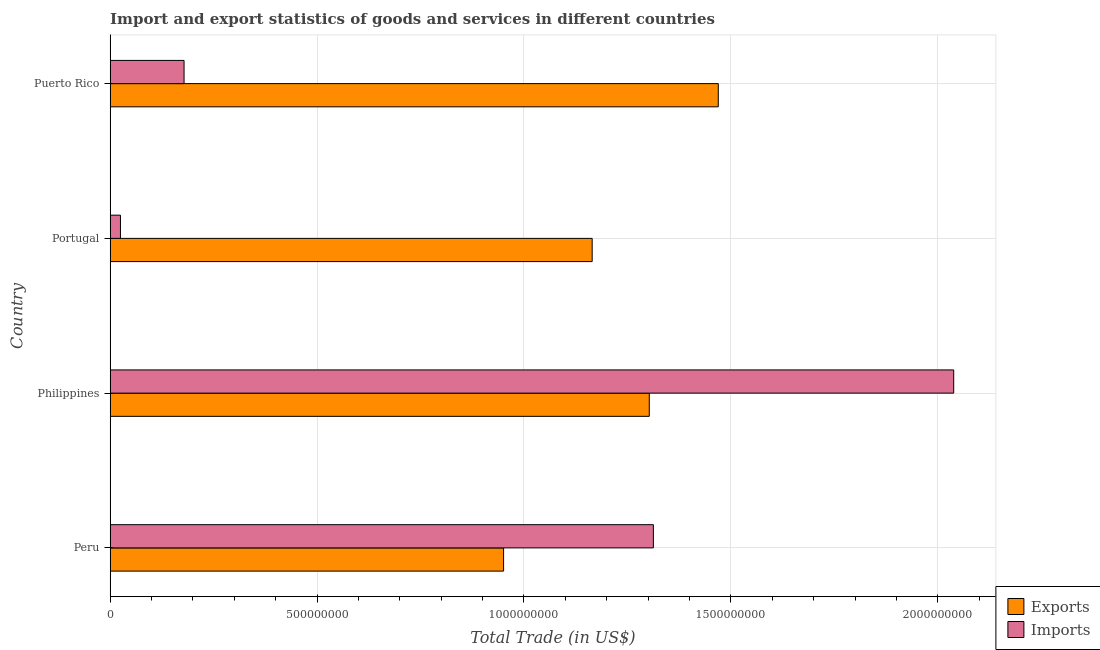How many different coloured bars are there?
Ensure brevity in your answer.  2. How many groups of bars are there?
Keep it short and to the point. 4. What is the imports of goods and services in Philippines?
Give a very brief answer. 2.04e+09. Across all countries, what is the maximum export of goods and services?
Your answer should be compact. 1.47e+09. Across all countries, what is the minimum export of goods and services?
Your response must be concise. 9.51e+08. In which country was the export of goods and services minimum?
Offer a terse response. Peru. What is the total imports of goods and services in the graph?
Your answer should be compact. 3.55e+09. What is the difference between the imports of goods and services in Peru and that in Puerto Rico?
Your response must be concise. 1.13e+09. What is the difference between the export of goods and services in Philippines and the imports of goods and services in Peru?
Make the answer very short. -9.93e+06. What is the average export of goods and services per country?
Keep it short and to the point. 1.22e+09. What is the difference between the imports of goods and services and export of goods and services in Puerto Rico?
Keep it short and to the point. -1.29e+09. In how many countries, is the imports of goods and services greater than 500000000 US$?
Provide a short and direct response. 2. What is the ratio of the export of goods and services in Peru to that in Philippines?
Make the answer very short. 0.73. Is the difference between the export of goods and services in Portugal and Puerto Rico greater than the difference between the imports of goods and services in Portugal and Puerto Rico?
Give a very brief answer. No. What is the difference between the highest and the second highest imports of goods and services?
Give a very brief answer. 7.26e+08. What is the difference between the highest and the lowest imports of goods and services?
Keep it short and to the point. 2.01e+09. What does the 2nd bar from the top in Peru represents?
Provide a succinct answer. Exports. What does the 1st bar from the bottom in Puerto Rico represents?
Your answer should be compact. Exports. How many bars are there?
Give a very brief answer. 8. Are all the bars in the graph horizontal?
Give a very brief answer. Yes. How many countries are there in the graph?
Keep it short and to the point. 4. Are the values on the major ticks of X-axis written in scientific E-notation?
Offer a very short reply. No. How many legend labels are there?
Offer a very short reply. 2. What is the title of the graph?
Provide a short and direct response. Import and export statistics of goods and services in different countries. What is the label or title of the X-axis?
Give a very brief answer. Total Trade (in US$). What is the label or title of the Y-axis?
Your answer should be very brief. Country. What is the Total Trade (in US$) in Exports in Peru?
Your answer should be compact. 9.51e+08. What is the Total Trade (in US$) of Imports in Peru?
Offer a terse response. 1.31e+09. What is the Total Trade (in US$) of Exports in Philippines?
Give a very brief answer. 1.30e+09. What is the Total Trade (in US$) of Imports in Philippines?
Provide a succinct answer. 2.04e+09. What is the Total Trade (in US$) of Exports in Portugal?
Keep it short and to the point. 1.16e+09. What is the Total Trade (in US$) of Imports in Portugal?
Keep it short and to the point. 2.49e+07. What is the Total Trade (in US$) in Exports in Puerto Rico?
Give a very brief answer. 1.47e+09. What is the Total Trade (in US$) in Imports in Puerto Rico?
Give a very brief answer. 1.79e+08. Across all countries, what is the maximum Total Trade (in US$) in Exports?
Ensure brevity in your answer.  1.47e+09. Across all countries, what is the maximum Total Trade (in US$) of Imports?
Offer a terse response. 2.04e+09. Across all countries, what is the minimum Total Trade (in US$) of Exports?
Give a very brief answer. 9.51e+08. Across all countries, what is the minimum Total Trade (in US$) in Imports?
Your response must be concise. 2.49e+07. What is the total Total Trade (in US$) of Exports in the graph?
Make the answer very short. 4.89e+09. What is the total Total Trade (in US$) of Imports in the graph?
Make the answer very short. 3.55e+09. What is the difference between the Total Trade (in US$) in Exports in Peru and that in Philippines?
Ensure brevity in your answer.  -3.52e+08. What is the difference between the Total Trade (in US$) in Imports in Peru and that in Philippines?
Ensure brevity in your answer.  -7.26e+08. What is the difference between the Total Trade (in US$) in Exports in Peru and that in Portugal?
Provide a succinct answer. -2.14e+08. What is the difference between the Total Trade (in US$) of Imports in Peru and that in Portugal?
Your answer should be compact. 1.29e+09. What is the difference between the Total Trade (in US$) in Exports in Peru and that in Puerto Rico?
Keep it short and to the point. -5.19e+08. What is the difference between the Total Trade (in US$) in Imports in Peru and that in Puerto Rico?
Make the answer very short. 1.13e+09. What is the difference between the Total Trade (in US$) of Exports in Philippines and that in Portugal?
Keep it short and to the point. 1.38e+08. What is the difference between the Total Trade (in US$) in Imports in Philippines and that in Portugal?
Ensure brevity in your answer.  2.01e+09. What is the difference between the Total Trade (in US$) in Exports in Philippines and that in Puerto Rico?
Give a very brief answer. -1.67e+08. What is the difference between the Total Trade (in US$) in Imports in Philippines and that in Puerto Rico?
Your answer should be compact. 1.86e+09. What is the difference between the Total Trade (in US$) of Exports in Portugal and that in Puerto Rico?
Give a very brief answer. -3.05e+08. What is the difference between the Total Trade (in US$) in Imports in Portugal and that in Puerto Rico?
Provide a short and direct response. -1.54e+08. What is the difference between the Total Trade (in US$) of Exports in Peru and the Total Trade (in US$) of Imports in Philippines?
Keep it short and to the point. -1.09e+09. What is the difference between the Total Trade (in US$) in Exports in Peru and the Total Trade (in US$) in Imports in Portugal?
Your answer should be compact. 9.26e+08. What is the difference between the Total Trade (in US$) in Exports in Peru and the Total Trade (in US$) in Imports in Puerto Rico?
Provide a short and direct response. 7.72e+08. What is the difference between the Total Trade (in US$) in Exports in Philippines and the Total Trade (in US$) in Imports in Portugal?
Offer a terse response. 1.28e+09. What is the difference between the Total Trade (in US$) of Exports in Philippines and the Total Trade (in US$) of Imports in Puerto Rico?
Your answer should be very brief. 1.12e+09. What is the difference between the Total Trade (in US$) of Exports in Portugal and the Total Trade (in US$) of Imports in Puerto Rico?
Your answer should be compact. 9.86e+08. What is the average Total Trade (in US$) of Exports per country?
Provide a succinct answer. 1.22e+09. What is the average Total Trade (in US$) of Imports per country?
Your answer should be very brief. 8.89e+08. What is the difference between the Total Trade (in US$) of Exports and Total Trade (in US$) of Imports in Peru?
Your response must be concise. -3.62e+08. What is the difference between the Total Trade (in US$) of Exports and Total Trade (in US$) of Imports in Philippines?
Your response must be concise. -7.36e+08. What is the difference between the Total Trade (in US$) in Exports and Total Trade (in US$) in Imports in Portugal?
Provide a short and direct response. 1.14e+09. What is the difference between the Total Trade (in US$) of Exports and Total Trade (in US$) of Imports in Puerto Rico?
Your response must be concise. 1.29e+09. What is the ratio of the Total Trade (in US$) of Exports in Peru to that in Philippines?
Provide a short and direct response. 0.73. What is the ratio of the Total Trade (in US$) in Imports in Peru to that in Philippines?
Your response must be concise. 0.64. What is the ratio of the Total Trade (in US$) in Exports in Peru to that in Portugal?
Make the answer very short. 0.82. What is the ratio of the Total Trade (in US$) in Imports in Peru to that in Portugal?
Your response must be concise. 52.72. What is the ratio of the Total Trade (in US$) of Exports in Peru to that in Puerto Rico?
Provide a short and direct response. 0.65. What is the ratio of the Total Trade (in US$) of Imports in Peru to that in Puerto Rico?
Your response must be concise. 7.35. What is the ratio of the Total Trade (in US$) in Exports in Philippines to that in Portugal?
Offer a very short reply. 1.12. What is the ratio of the Total Trade (in US$) in Imports in Philippines to that in Portugal?
Provide a short and direct response. 81.86. What is the ratio of the Total Trade (in US$) of Exports in Philippines to that in Puerto Rico?
Offer a very short reply. 0.89. What is the ratio of the Total Trade (in US$) in Imports in Philippines to that in Puerto Rico?
Make the answer very short. 11.41. What is the ratio of the Total Trade (in US$) of Exports in Portugal to that in Puerto Rico?
Your answer should be very brief. 0.79. What is the ratio of the Total Trade (in US$) in Imports in Portugal to that in Puerto Rico?
Ensure brevity in your answer.  0.14. What is the difference between the highest and the second highest Total Trade (in US$) of Exports?
Your answer should be very brief. 1.67e+08. What is the difference between the highest and the second highest Total Trade (in US$) in Imports?
Your answer should be compact. 7.26e+08. What is the difference between the highest and the lowest Total Trade (in US$) in Exports?
Provide a succinct answer. 5.19e+08. What is the difference between the highest and the lowest Total Trade (in US$) of Imports?
Provide a succinct answer. 2.01e+09. 